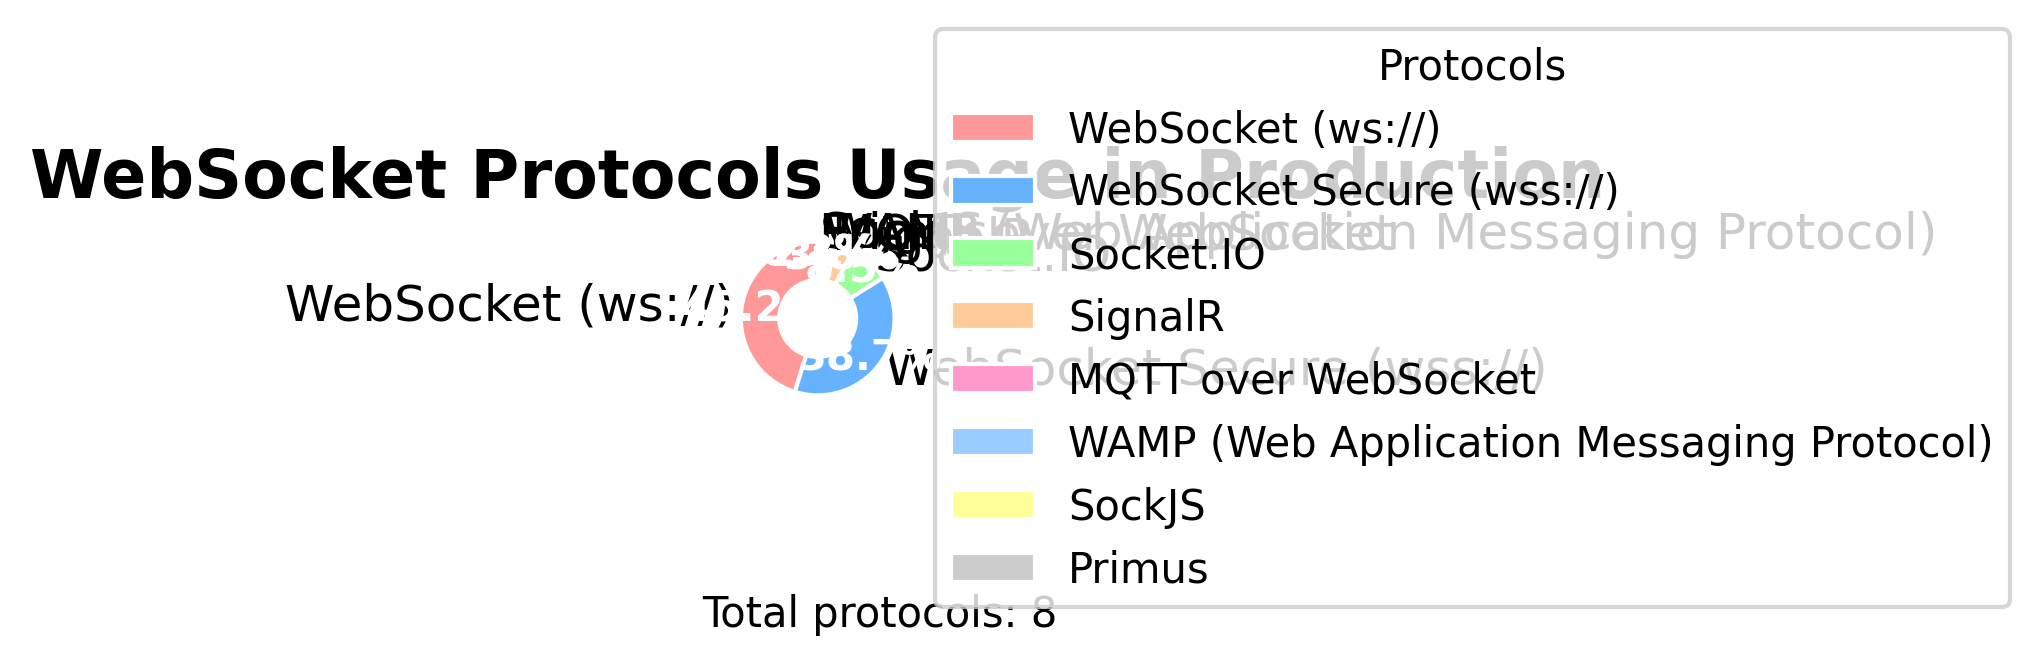Which protocol has the highest usage percentage in production environments? The protocol with the highest usage percentage can be identified by looking for the largest segment in the pie chart, which is labeled and has the percentage noted. "WebSocket (ws://)" occupies the largest segment with 45.2%.
Answer: WebSocket (ws://) Which protocol has a smaller share, SockJS or Primus? To compare the shares of SockJS and Primus, look at the respective segments of the pie chart. SockJS has a share of 0.3%, while Primus has a smaller share of 0.2%.
Answer: Primus What is the combined proportion of WebSocket Secure (wss://) and Socket.IO? To get the combined proportion, sum the percentages of WebSocket Secure (38.7%) and Socket.IO (8.5%). The sum is 38.7 + 8.5 = 47.2%.
Answer: 47.2% Is the proportion of SignalR usage greater than MQTT over WebSocket? Compare the sizes of the segments for SignalR and MQTT over WebSocket. SignalR has a usage percentage of 3.8%, whereas MQTT over WebSocket has 2.1%, meaning SignalR has a larger share.
Answer: Yes What is the total proportion of all protocols other than WebSocket (ws://)? First identify the percentage for WebSocket (ws://), which is 45.2%. Then sum up the percentages of all other protocols: 38.7 + 8.5 + 3.8 + 2.1 + 1.2 + 0.3 + 0.2 = 54.8%.
Answer: 54.8% How many protocols have a proportion less than 5%? Identify all protocols with a segment less than 5%: Socket.IO (8.5%), WebSocket Secure (38.7%), and WebSocket (ws://) (45.2%) are greater. Remaining are SignalR (3.8%), MQTT over WebSocket (2.1%), WAMP (1.2%), SockJS (0.3%), and Primus (0.2%) – a total of 5 protocols.
Answer: 5 Which protocol is represented by the segment colored red? The pie chart uses various colors for different segments. The red segment, identified by its color and corresponding label, represents WebSocket (ws://).
Answer: WebSocket (ws://) What's the difference in the usage proportions between the two most-used protocols? The two most-used protocols are WebSocket (45.2%) and WebSocket Secure (38.7%). The difference is calculated as 45.2% - 38.7% = 6.5%.
Answer: 6.5% What is the average usage percentage of the protocols excluding WebSocket (ws://) and WebSocket Secure (wss://)? Exclude WebSocket (45.2%) and WebSocket Secure (38.7%) and calculate the average of the remaining percentages: (8.5 + 3.8 + 2.1 + 1.2 + 0.3 + 0.2) / 6 = 16.1 / 6 ≈ 2.68%.
Answer: 2.68% Which protocol has a usage percentage that falls between those of SignalR and Socket.IO? SignalR has a usage percentage of 3.8%, and Socket.IO has 8.5%. The protocol whose percentage falls between these values is MQTT over WebSocket with 2.1%.
Answer: MQTT over WebSocket 